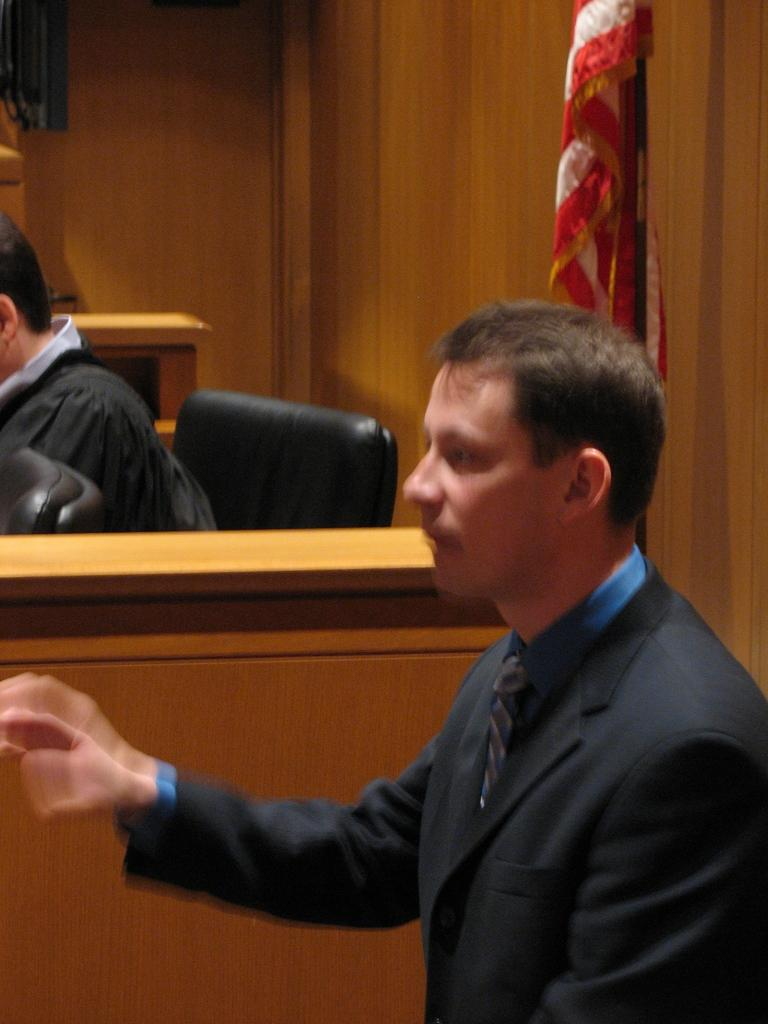What is present in the image? There is a person and another person sitting on a chair in the image. What can be seen in the background of the image? There is a flag in the background of the image. How many rabbits are visible in the image? There are no rabbits present in the image. What is the weight of the person sitting on the chair? The weight of the person sitting on the chair cannot be determined from the image. 